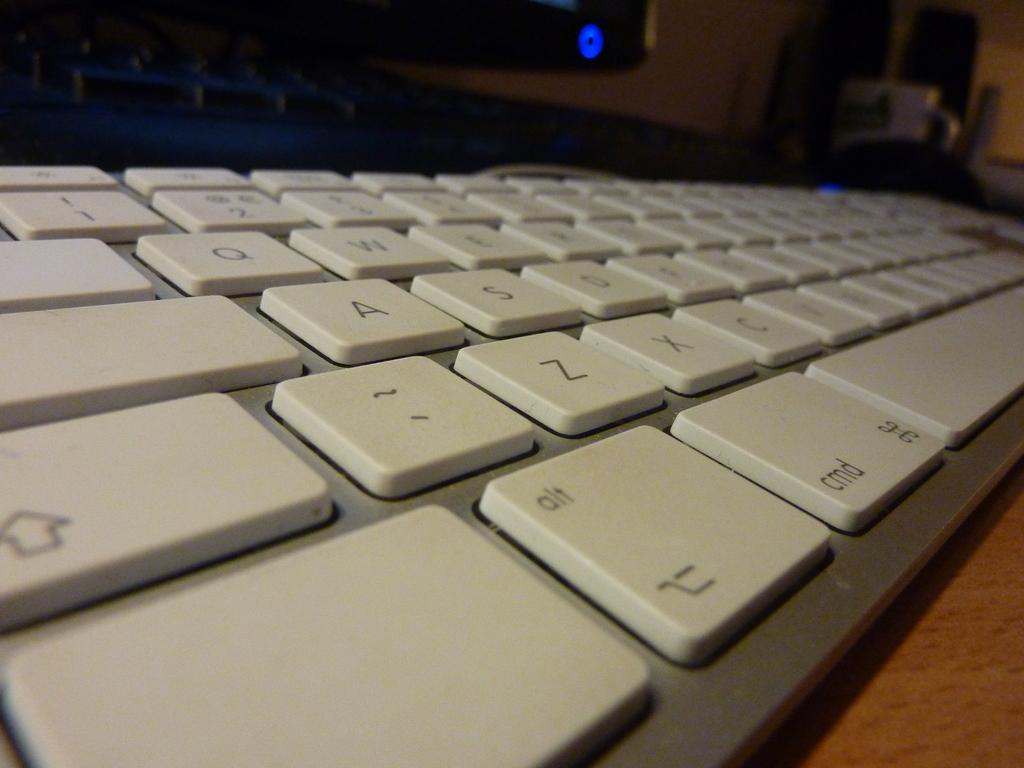What keys can you read on the keyboard that are visible?
Offer a terse response. Aly. Which letter is displayed on the key above a?
Your response must be concise. Q. 